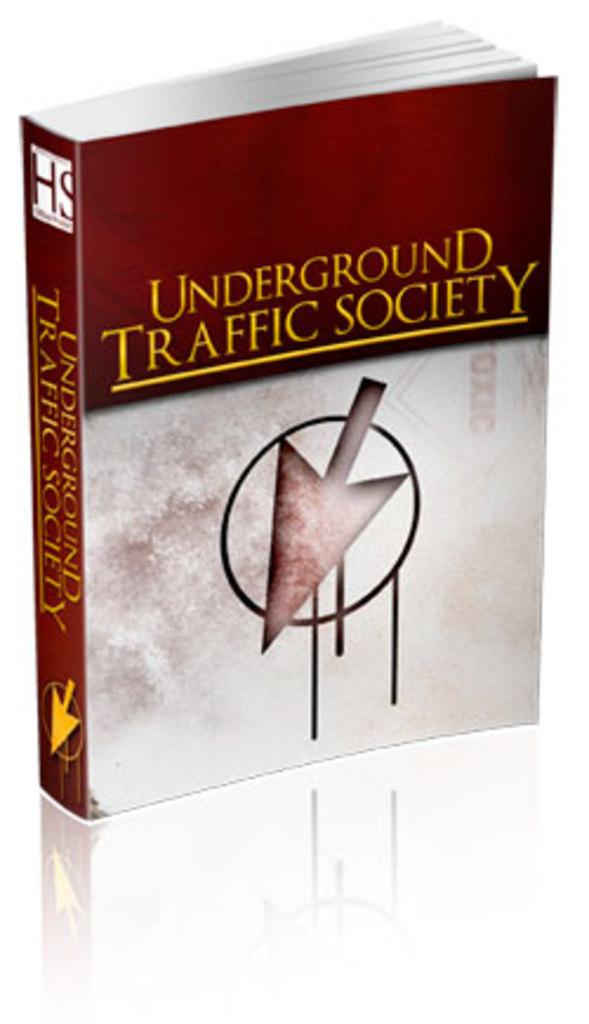What kind of underground society is the book about?
Keep it short and to the point. Traffic. What are the letter on the top left?
Your response must be concise. Hs. 